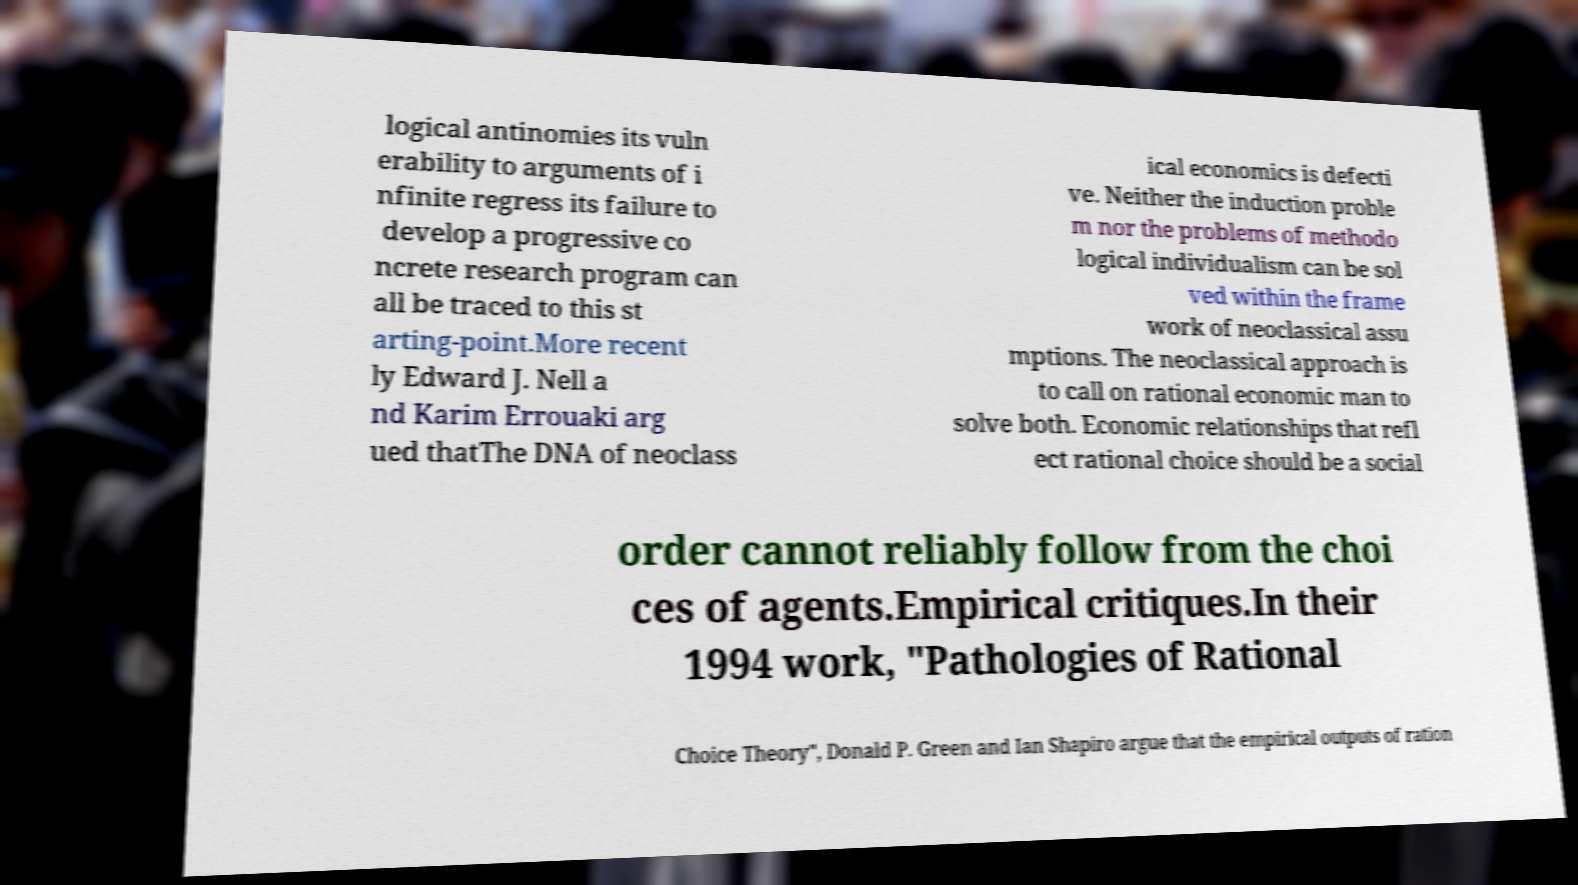Can you accurately transcribe the text from the provided image for me? logical antinomies its vuln erability to arguments of i nfinite regress its failure to develop a progressive co ncrete research program can all be traced to this st arting-point.More recent ly Edward J. Nell a nd Karim Errouaki arg ued thatThe DNA of neoclass ical economics is defecti ve. Neither the induction proble m nor the problems of methodo logical individualism can be sol ved within the frame work of neoclassical assu mptions. The neoclassical approach is to call on rational economic man to solve both. Economic relationships that refl ect rational choice should be a social order cannot reliably follow from the choi ces of agents.Empirical critiques.In their 1994 work, "Pathologies of Rational Choice Theory", Donald P. Green and Ian Shapiro argue that the empirical outputs of ration 